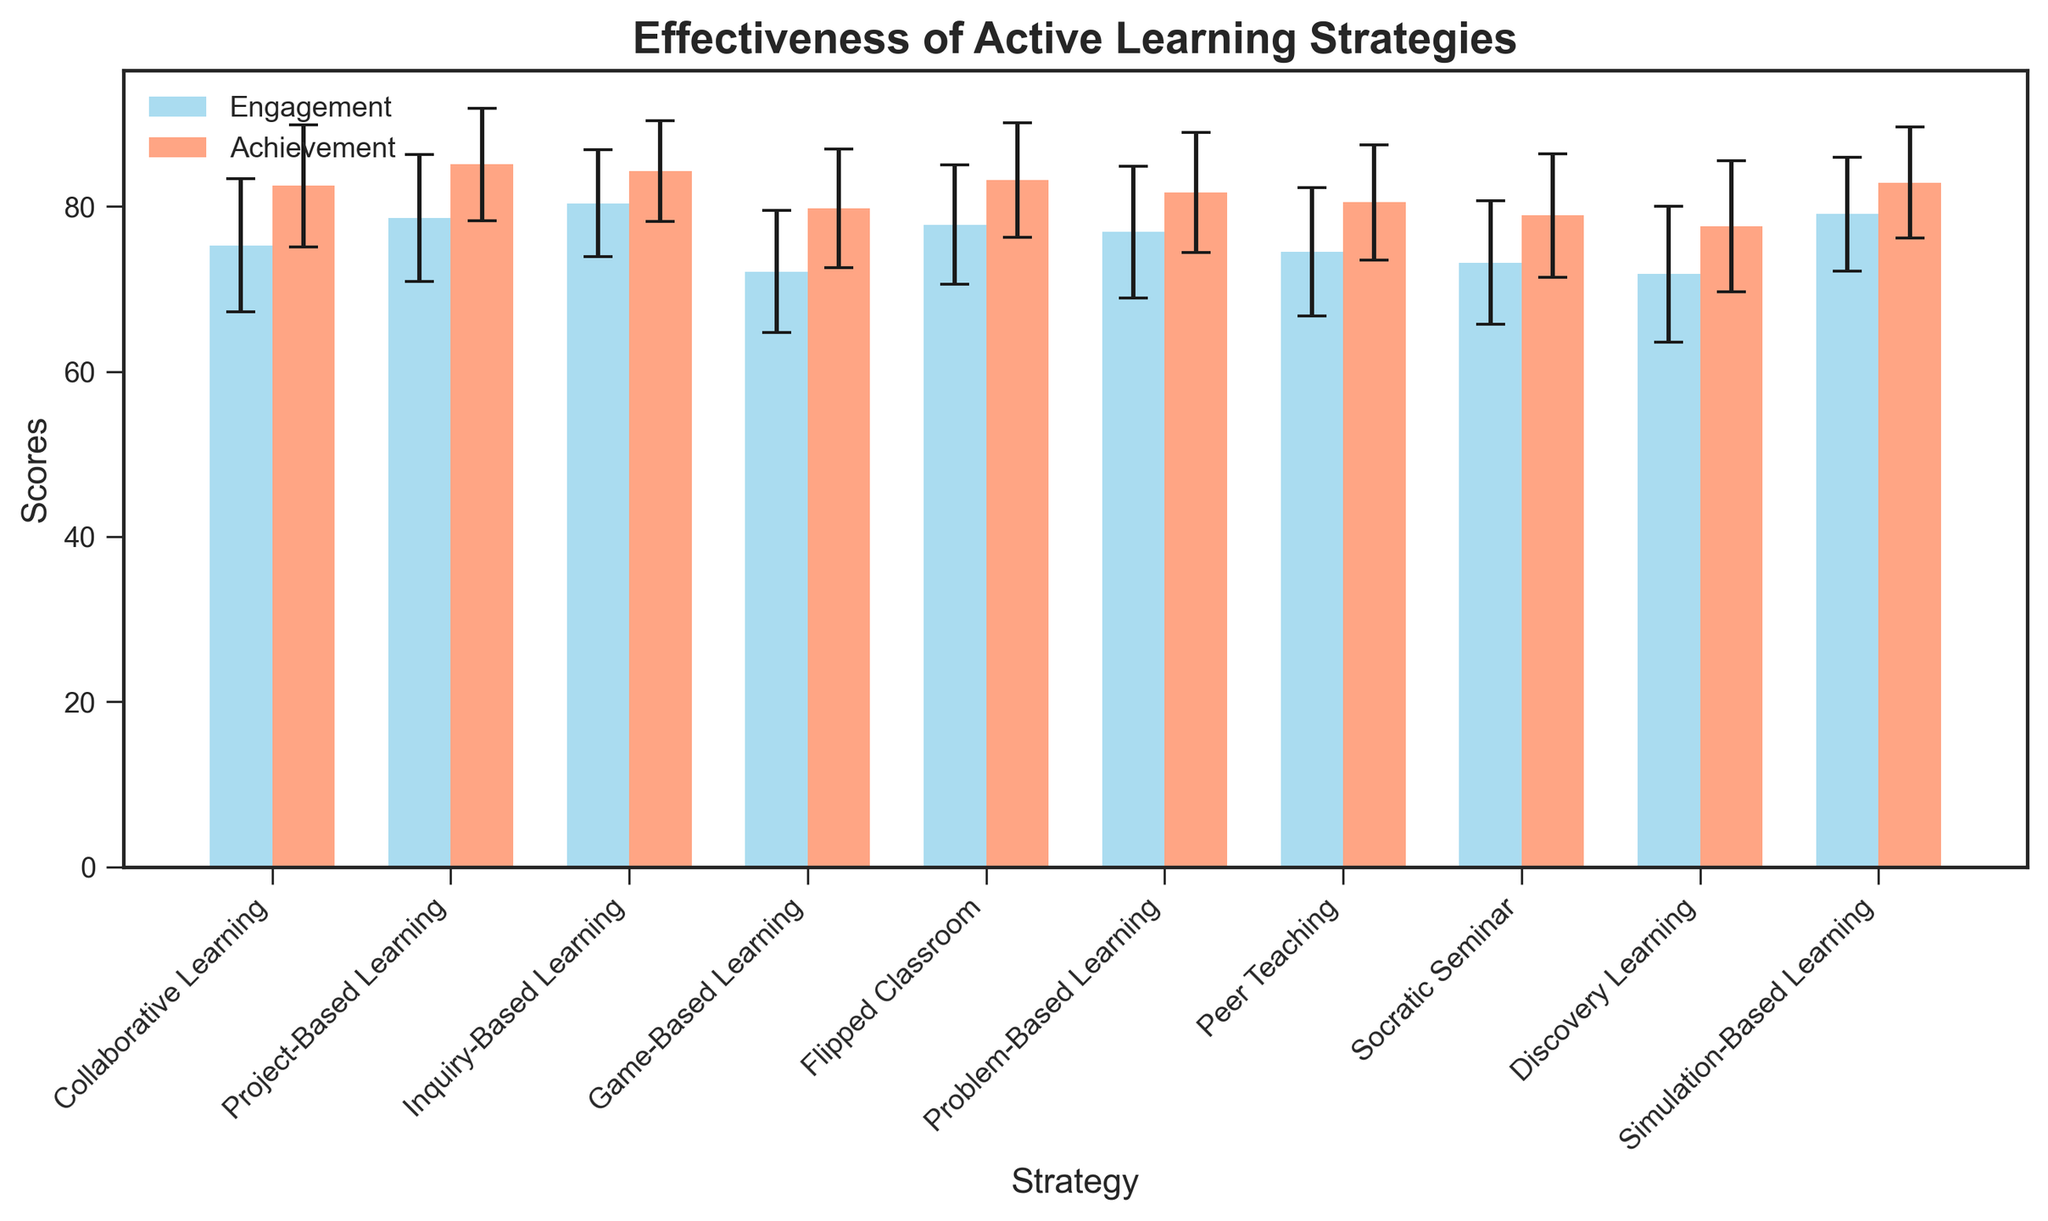What strategy shows the highest mean student engagement? The strategy with the highest mean student engagement can be determined by looking at the height of the blue bars. Inquiry-Based Learning has the highest bar, indicating the highest mean engagement at 80.4.
Answer: Inquiry-Based Learning Which strategy has the lowest mean achievement? The strategy with the lowest mean achievement can be identified by looking at the heights of the red bars. Discovery Learning has the shortest red bar with a mean achievement score of 77.6.
Answer: Discovery Learning Between which two strategies is the difference in mean engagement the greatest? To determine this, calculate the absolute differences in mean engagement between each pair of strategies and find the maximum value. The greatest difference is between Discovery Learning (71.8) and Inquiry-Based Learning (80.4).
Answer: Discovery Learning and Inquiry-Based Learning Which strategy has the closest mean engagement and achievement scores? To find this, calculate the absolute difference between the mean engagement and achievement for each strategy and find the smallest difference. Inquiry-Based Learning has scores of 80.4 (mean engagement) and 84.3 (mean achievement), making the difference 3.9, which is the smallest among all strategies.
Answer: Inquiry-Based Learning What is the average mean achievement score across all strategies? To calculate the average mean achievement, sum all mean achievement scores and divide by the number of strategies. The sum is 82.5+85.1+84.3+79.8+83.2+81.7+80.5+78.9+77.6+82.9 = 816.5. Dividing this by 10 strategies gives an average of 81.65.
Answer: 81.65 Which strategy has the largest variability in achievement scores? Variability can be determined by looking at the standard deviation (error bars) of the achievement scores. Discovery Learning has the largest error bar in red, indicating the highest standard deviation of 7.9.
Answer: Discovery Learning Which two strategies have the smallest difference in mean engagement? To determine this, calculate the absolute differences in mean engagement between each pair of strategies and find the smallest value. The smallest difference is between Collaborative Learning (75.3) and Problem-Based Learning (76.9), which is 1.6.
Answer: Collaborative Learning and Problem-Based Learning What is the total mean engagement score for all strategies combined? To find this, sum all the mean engagement scores. The total mean engagement is 75.3+78.6+80.4+72.1+77.8+76.9+74.5+73.2+71.8+79.1 = 759.7.
Answer: 759.7 Which strategy has the second-highest mean achievement score? By comparing the heights of the red bars, we can identify that Project-Based Learning has the second-highest mean achievement score at 85.1, just below Inquiry-Based Learning.
Answer: Project-Based Learning What is the mean engagement score for Flipped Classroom, and how does its variability compare to Game-Based Learning? The mean engagement score for Flipped Classroom is 77.8. Comparing the error bars, the standard deviation (variability) for Flipped Classroom (7.2) is lower than that of Game-Based Learning (7.4).
Answer: 77.8 and lower 